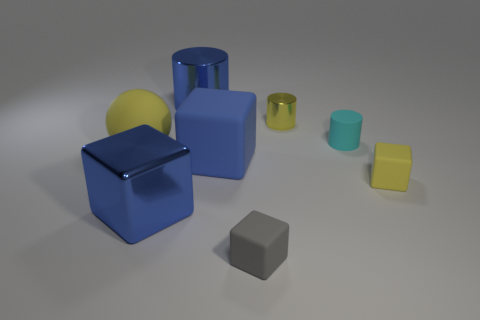Subtract 1 blocks. How many blocks are left? 3 Add 1 big balls. How many objects exist? 9 Subtract all spheres. How many objects are left? 7 Add 4 blue metallic things. How many blue metallic things are left? 6 Add 6 large cylinders. How many large cylinders exist? 7 Subtract 1 gray blocks. How many objects are left? 7 Subtract all tiny gray matte cubes. Subtract all big blue rubber objects. How many objects are left? 6 